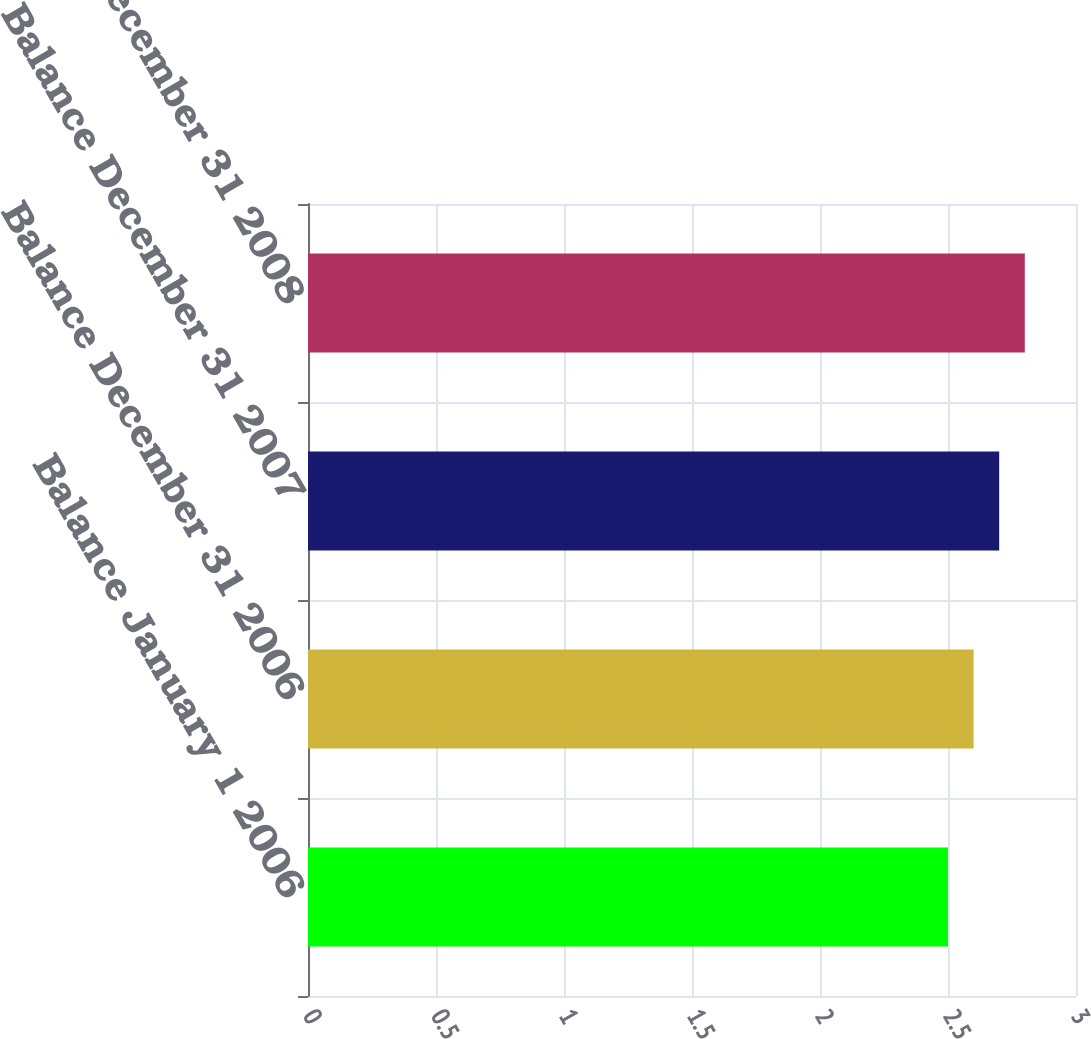Convert chart. <chart><loc_0><loc_0><loc_500><loc_500><bar_chart><fcel>Balance January 1 2006<fcel>Balance December 31 2006<fcel>Balance December 31 2007<fcel>Balance December 31 2008<nl><fcel>2.5<fcel>2.6<fcel>2.7<fcel>2.8<nl></chart> 